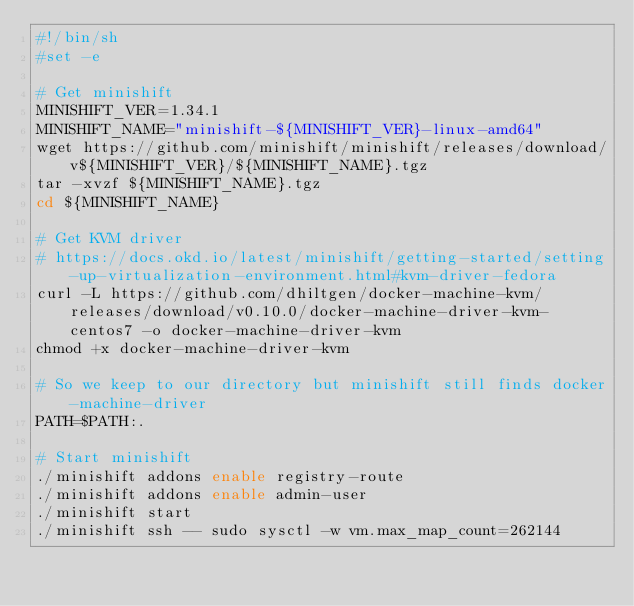<code> <loc_0><loc_0><loc_500><loc_500><_Bash_>#!/bin/sh
#set -e

# Get minishift
MINISHIFT_VER=1.34.1
MINISHIFT_NAME="minishift-${MINISHIFT_VER}-linux-amd64"
wget https://github.com/minishift/minishift/releases/download/v${MINISHIFT_VER}/${MINISHIFT_NAME}.tgz
tar -xvzf ${MINISHIFT_NAME}.tgz
cd ${MINISHIFT_NAME}

# Get KVM driver
# https://docs.okd.io/latest/minishift/getting-started/setting-up-virtualization-environment.html#kvm-driver-fedora
curl -L https://github.com/dhiltgen/docker-machine-kvm/releases/download/v0.10.0/docker-machine-driver-kvm-centos7 -o docker-machine-driver-kvm
chmod +x docker-machine-driver-kvm

# So we keep to our directory but minishift still finds docker-machine-driver
PATH=$PATH:.

# Start minishift
./minishift addons enable registry-route
./minishift addons enable admin-user
./minishift start
./minishift ssh -- sudo sysctl -w vm.max_map_count=262144</code> 